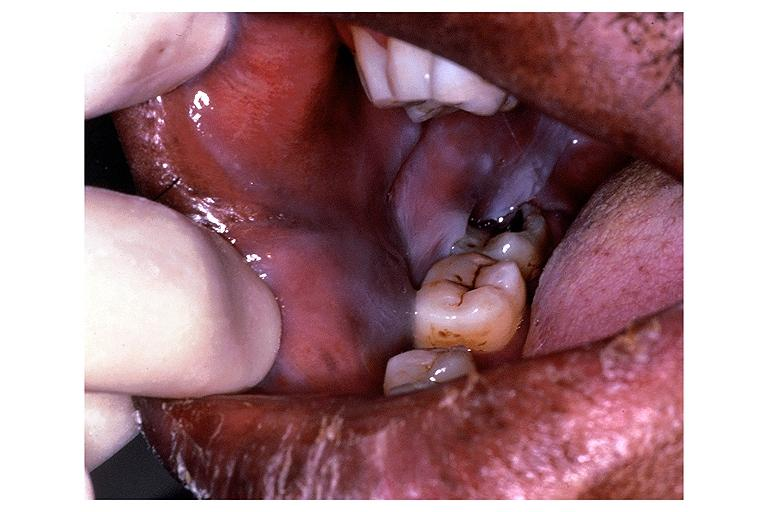s this image shows of smooth muscle cell with lipid in sarcoplasm and lipid present?
Answer the question using a single word or phrase. No 